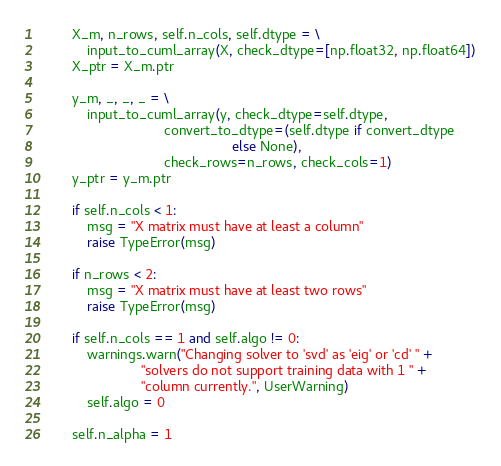Convert code to text. <code><loc_0><loc_0><loc_500><loc_500><_Cython_>        X_m, n_rows, self.n_cols, self.dtype = \
            input_to_cuml_array(X, check_dtype=[np.float32, np.float64])
        X_ptr = X_m.ptr

        y_m, _, _, _ = \
            input_to_cuml_array(y, check_dtype=self.dtype,
                                convert_to_dtype=(self.dtype if convert_dtype
                                                  else None),
                                check_rows=n_rows, check_cols=1)
        y_ptr = y_m.ptr

        if self.n_cols < 1:
            msg = "X matrix must have at least a column"
            raise TypeError(msg)

        if n_rows < 2:
            msg = "X matrix must have at least two rows"
            raise TypeError(msg)

        if self.n_cols == 1 and self.algo != 0:
            warnings.warn("Changing solver to 'svd' as 'eig' or 'cd' " +
                          "solvers do not support training data with 1 " +
                          "column currently.", UserWarning)
            self.algo = 0

        self.n_alpha = 1
</code> 